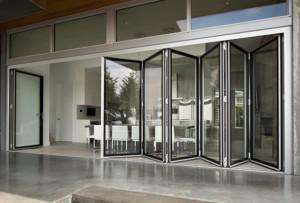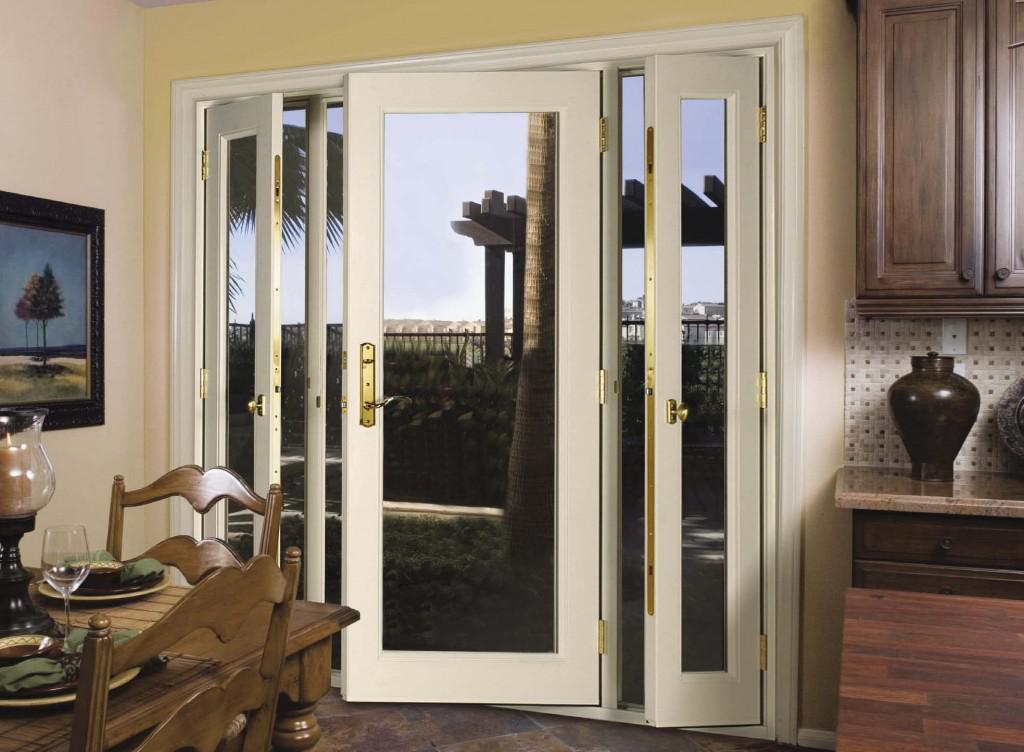The first image is the image on the left, the second image is the image on the right. Considering the images on both sides, is "An image shows a row of hinged glass panels forming an accordion-like pattern." valid? Answer yes or no. Yes. The first image is the image on the left, the second image is the image on the right. Considering the images on both sides, is "Both sets of doors in the images are white." valid? Answer yes or no. No. 